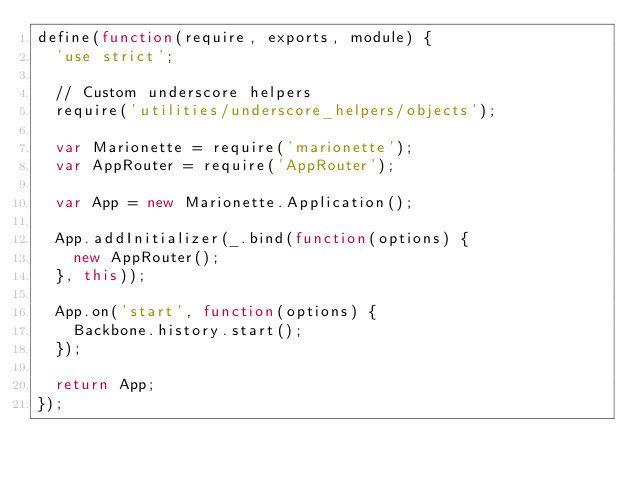<code> <loc_0><loc_0><loc_500><loc_500><_JavaScript_>define(function(require, exports, module) {
  'use strict';

  // Custom underscore helpers
  require('utilities/underscore_helpers/objects');

  var Marionette = require('marionette');
  var AppRouter = require('AppRouter');

  var App = new Marionette.Application();

  App.addInitializer(_.bind(function(options) {
    new AppRouter();
  }, this));

  App.on('start', function(options) {
    Backbone.history.start();
  });

  return App;
});</code> 